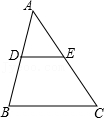First perform reasoning, then finally select the question from the choices in the following format: Answer: xxx.
Question: In triangle ABC, D and E are the midpoints of the sides AB and AC respectively. If the perimeter of triangle ADE is 30 units, then what is the perimeter of triangle ABC?
Choices:
A: 30.0
B: 60.0
C: 90.0
D: 120.0 Because D and E are the midpoints of AB and AC respectively, thus AD = 0.5 × AB, AE = 0.5 × AC, DE = 0.5 × BC. So the perimeter of triangle ABC = AB + AC + BC = 2AD + 2AE + 2DE = 2(AD + AE + DE) = 2 × 30 = 60. Therefore, the answer is B.
Answer:B 